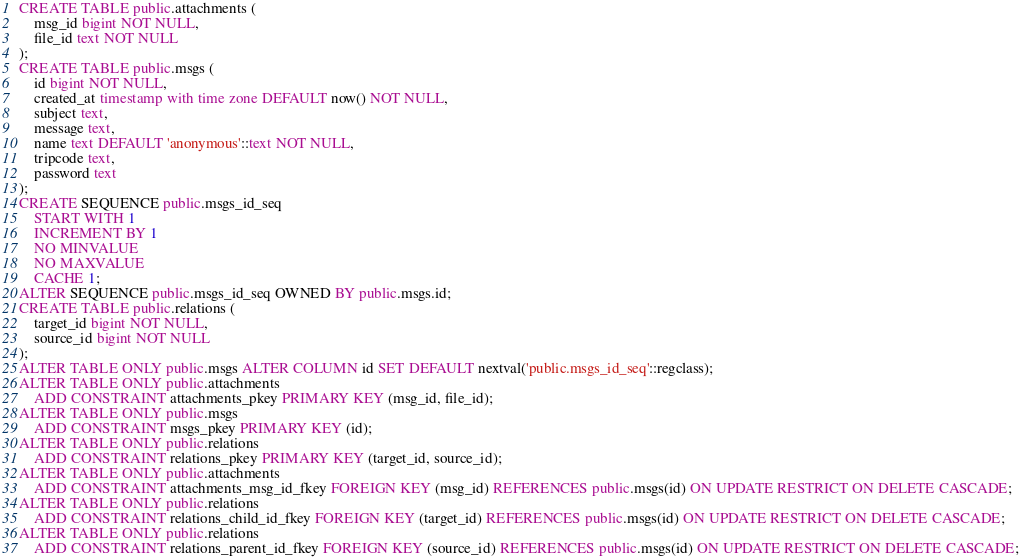<code> <loc_0><loc_0><loc_500><loc_500><_SQL_>CREATE TABLE public.attachments (
    msg_id bigint NOT NULL,
    file_id text NOT NULL
);
CREATE TABLE public.msgs (
    id bigint NOT NULL,
    created_at timestamp with time zone DEFAULT now() NOT NULL,
    subject text,
    message text,
    name text DEFAULT 'anonymous'::text NOT NULL,
    tripcode text,
    password text
);
CREATE SEQUENCE public.msgs_id_seq
    START WITH 1
    INCREMENT BY 1
    NO MINVALUE
    NO MAXVALUE
    CACHE 1;
ALTER SEQUENCE public.msgs_id_seq OWNED BY public.msgs.id;
CREATE TABLE public.relations (
    target_id bigint NOT NULL,
    source_id bigint NOT NULL
);
ALTER TABLE ONLY public.msgs ALTER COLUMN id SET DEFAULT nextval('public.msgs_id_seq'::regclass);
ALTER TABLE ONLY public.attachments
    ADD CONSTRAINT attachments_pkey PRIMARY KEY (msg_id, file_id);
ALTER TABLE ONLY public.msgs
    ADD CONSTRAINT msgs_pkey PRIMARY KEY (id);
ALTER TABLE ONLY public.relations
    ADD CONSTRAINT relations_pkey PRIMARY KEY (target_id, source_id);
ALTER TABLE ONLY public.attachments
    ADD CONSTRAINT attachments_msg_id_fkey FOREIGN KEY (msg_id) REFERENCES public.msgs(id) ON UPDATE RESTRICT ON DELETE CASCADE;
ALTER TABLE ONLY public.relations
    ADD CONSTRAINT relations_child_id_fkey FOREIGN KEY (target_id) REFERENCES public.msgs(id) ON UPDATE RESTRICT ON DELETE CASCADE;
ALTER TABLE ONLY public.relations
    ADD CONSTRAINT relations_parent_id_fkey FOREIGN KEY (source_id) REFERENCES public.msgs(id) ON UPDATE RESTRICT ON DELETE CASCADE;
</code> 